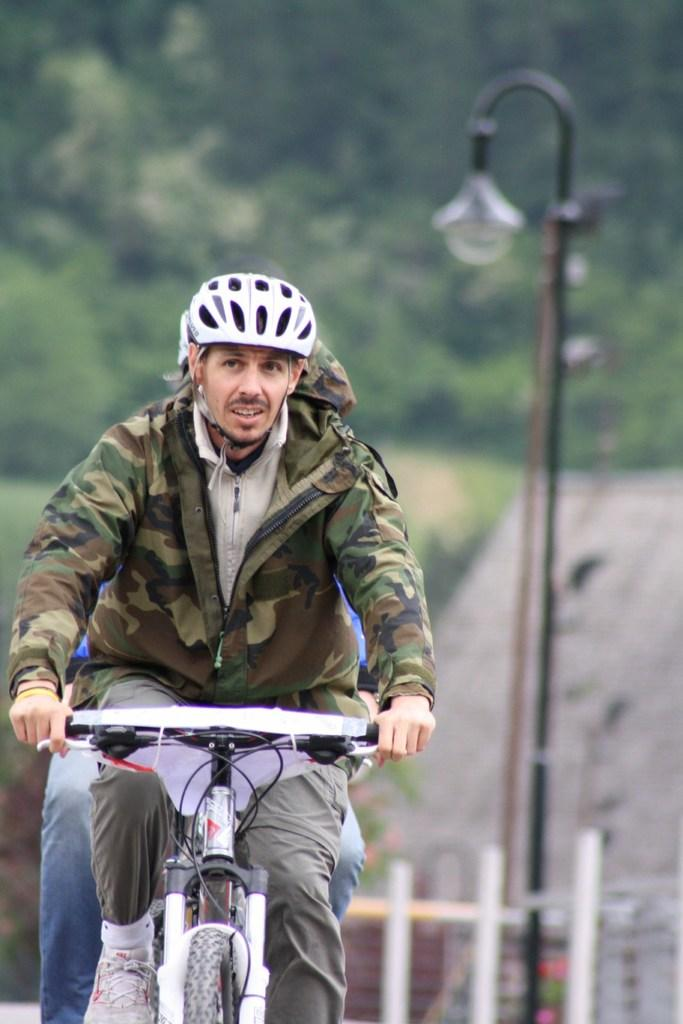What type of vegetation can be seen in the image? There are trees in the image. What is the man in the image doing? The man is riding a bicycle in the image. What can be seen on the right side of the image? There is a street lamp on the right side of the image. What type of impulse is the man riding in the image? The man is riding a bicycle, not an impulse, in the image. Can you tell me how many committee members are present in the image? There are no committee members present in the image. 